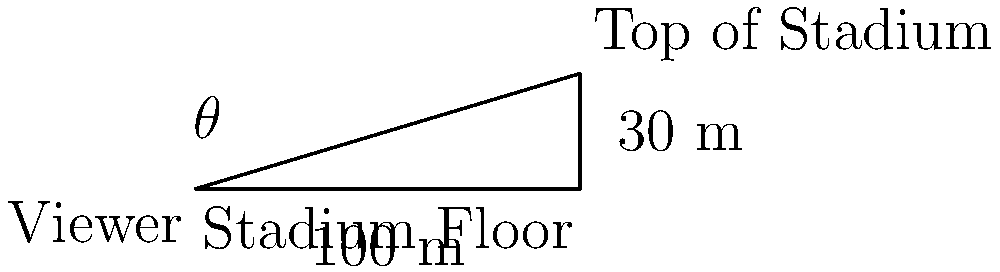As the owner of a sports team, you're redesigning the stadium to optimize viewer experience. Given a stadium with a height of 30 meters and a width of 100 meters, what is the viewing angle $\theta$ (in degrees) for a spectator sitting at ground level on one side of the stadium looking towards the top of the opposite side? To solve this problem, we'll use trigonometry. Let's approach this step-by-step:

1) We have a right triangle with:
   - The adjacent side (width of the stadium) = 100 meters
   - The opposite side (height of the stadium) = 30 meters

2) We need to find the angle $\theta$. In a right triangle, the tangent of an angle is the ratio of the opposite side to the adjacent side.

3) So, we can use the arctangent (tan^(-1)) function to find the angle:

   $\theta = \tan^{-1}(\frac{\text{opposite}}{\text{adjacent}})$

4) Plugging in our values:

   $\theta = \tan^{-1}(\frac{30}{100})$

5) Simplifying:

   $\theta = \tan^{-1}(0.3)$

6) Using a calculator or computer to evaluate this:

   $\theta \approx 16.70^\circ$

7) Rounding to two decimal places:

   $\theta \approx 16.70^\circ$

This angle represents the vertical field of view from the ground level to the top of the opposite side of the stadium. Understanding this can help in designing seating arrangements and considering factors like obstruction and visibility for spectators.
Answer: $16.70^\circ$ 